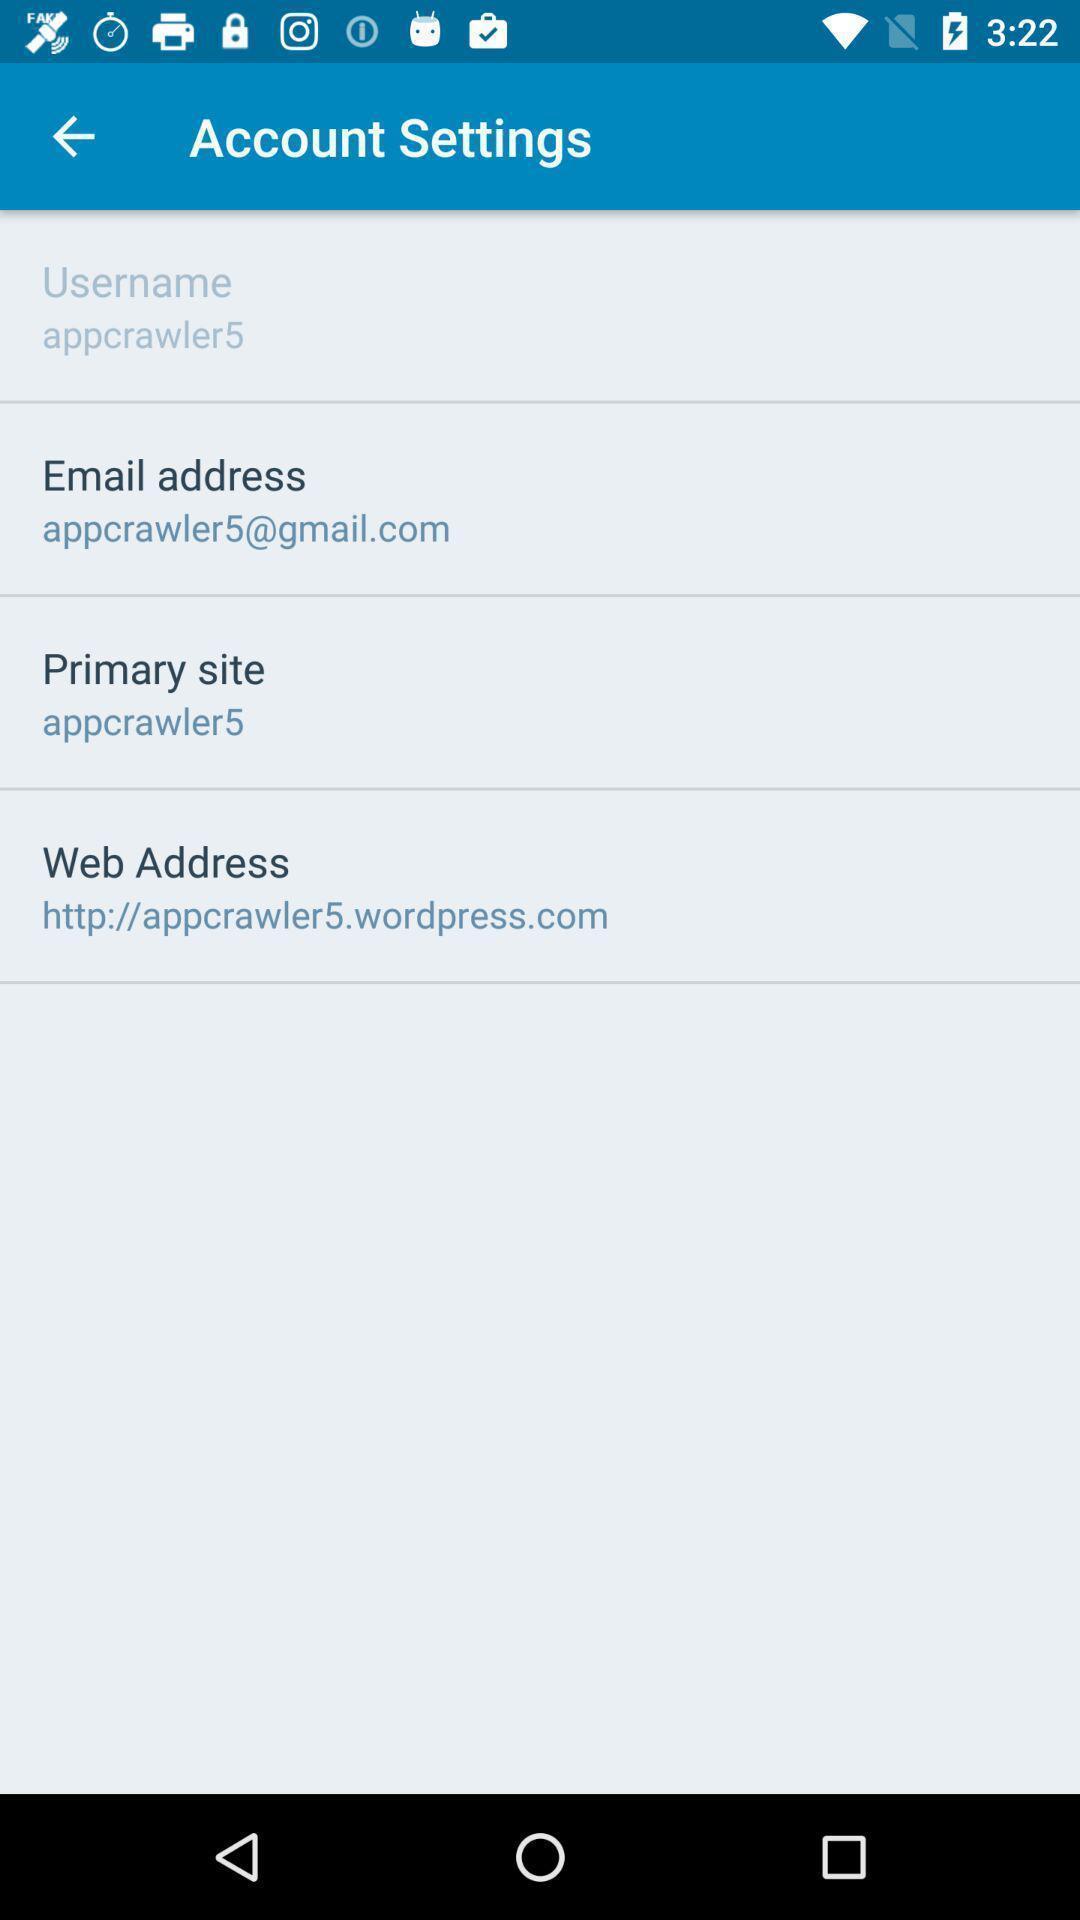Give me a summary of this screen capture. Screen page displaying the information in settings application. 